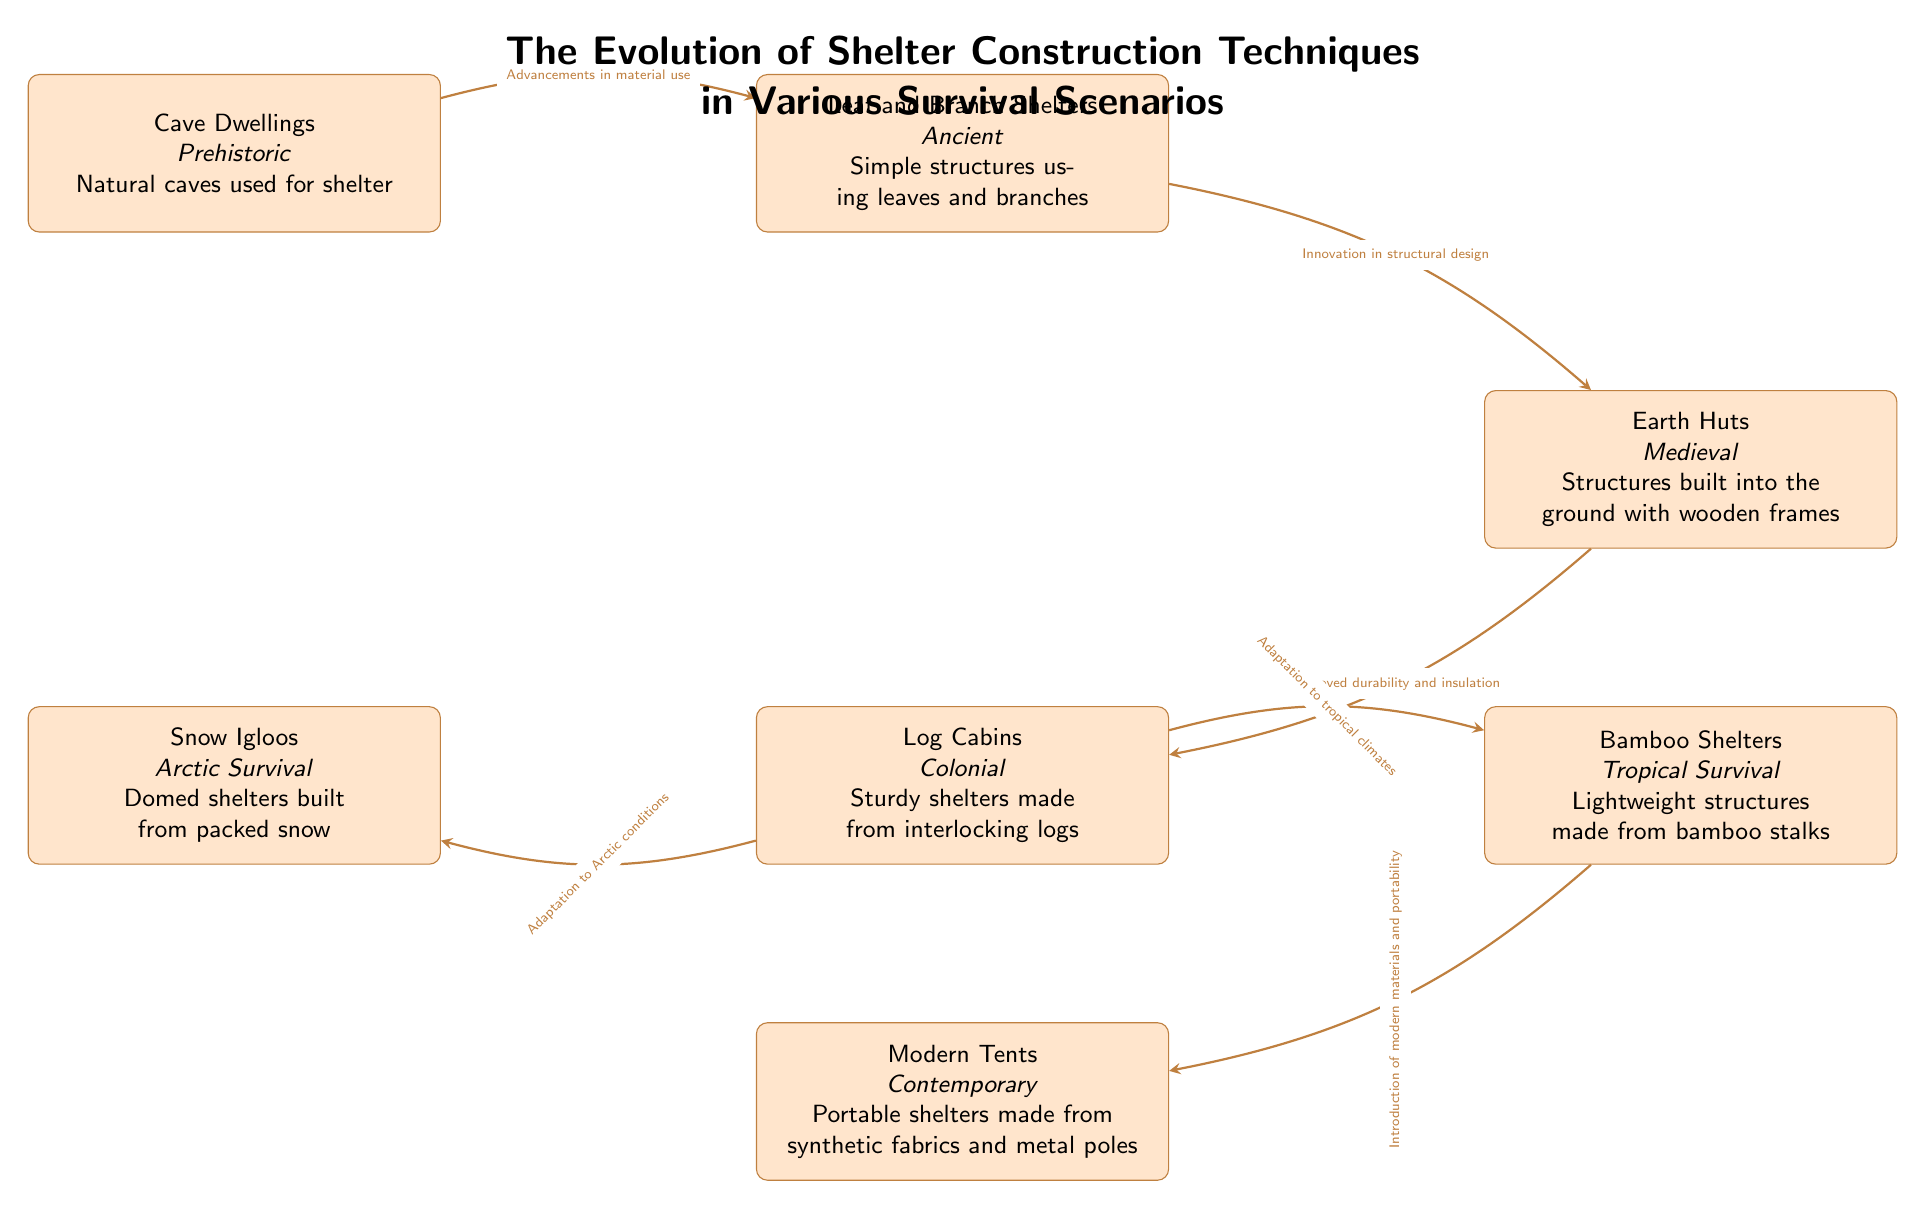What is the first type of shelter in the diagram? The first type of shelter listed in the diagram is Cave Dwellings, which are noted as prehistoric and made from natural caves.
Answer: Cave Dwellings How many different types of shelters are shown in the diagram? The diagram displays a total of six different types of shelters, ranging from cave dwellings to modern tents.
Answer: 6 What is the connection between Leaf and Branch Shelters and Earth Huts? The connection between these two shelters shows a progression where Leaf and Branch Shelters lead to Earth Huts, indicating innovation in structural design.
Answer: Innovation in structural design Which shelter is specifically designed for Arctic conditions? The shelter specifically designed for Arctic conditions is the Snow Igloo, which is built from packed snow to adapt to the environment.
Answer: Snow Igloos What type of shelter evolved from Log Cabins? The diagram indicates that adaptations from Log Cabins led to the design of both Snow Igloos and Bamboo Shelters, demonstrating how they evolved from the colonial method.
Answer: Snow Igloos and Bamboo Shelters What significant advancement is noted between Bamboo Shelters and Modern Tents? The significant advancement noted between Bamboo Shelters and Modern Tents is the introduction of modern materials and portability, enhancing the design and usability of shelters.
Answer: Introduction of modern materials and portability What historical period does the Log Cabin shelter belong to? The Log Cabin shelter is classified under the Colonial period, marking a specific phase in shelter construction techniques.
Answer: Colonial What natural materials were primarily used to build Leaf and Branch Shelters? Leaf and Branch Shelters primarily used leaves and branches, which are natural materials available in ancient settings.
Answer: Leaves and branches 